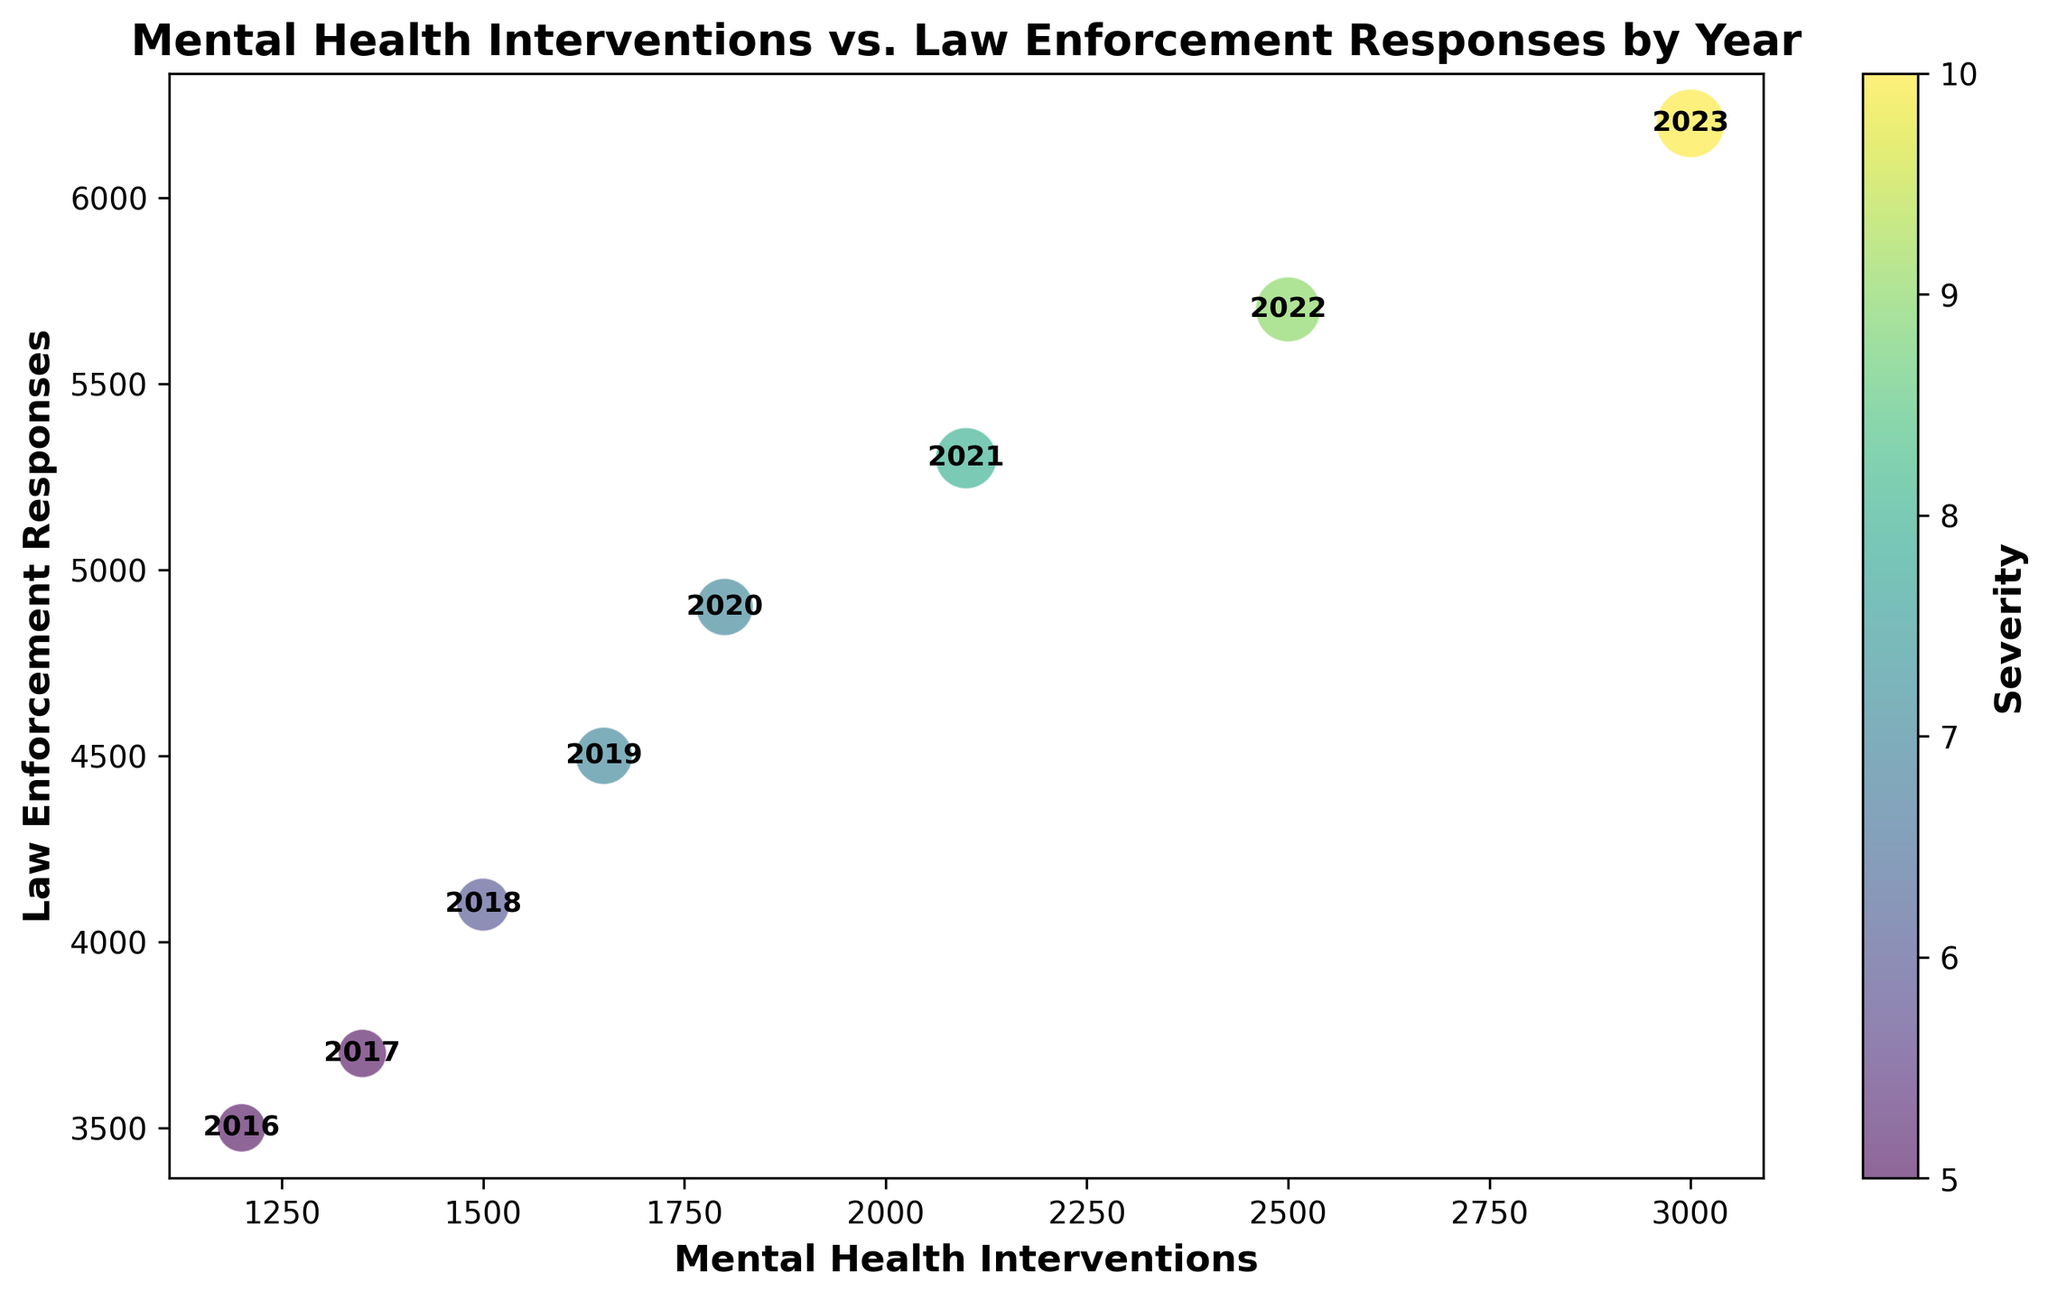What is the general trend of Mental Health Interventions from 2016 to 2023? By looking at the plot, you can see the bubbles representing Mental Health Interventions increase in value each year from left to right, indicating a consistent upward trend in the number of interventions from 2016 to 2023.
Answer: Increasing How does the number of Law Enforcement Responses in 2016 compare to 2023? By comparing the y-axis positions of the bubbles for 2016 and 2023, it is evident that the bubble for 2023 is higher than the one for 2016, indicating that Law Enforcement Responses have increased from 3500 in 2016 to 6200 in 2023.
Answer: Increased Which year had the highest severity level? By observing the size and color of the bubbles, the 2023 bubble is the largest and has the highest severity, represented by the deepest color, indicating the highest severity level of 10.
Answer: 2023 What is the difference in Mental Health Interventions between 2016 and 2023? The number of Mental Health Interventions for 2016 is 1200 and for 2023 is 3000. Subtracting the 2016 value from 2023 gives us 3000 - 1200 = 1800.
Answer: 1800 What is the ratio of Law Enforcement Responses to Mental Health Interventions in 2020? In 2020, there were 4900 Law Enforcement Responses and 1800 Mental Health Interventions. The ratio is 4900 / 1800 = 2.72.
Answer: 2.72 Which year saw the largest increase in Law Enforcement Responses compared to the previous year? By comparing the y-axis values year by year, the largest increase is between 2020 (4900) and 2021 (5300). The increase is 5300 - 4900 = 400.
Answer: 2021 Is the rate of increase in Mental Health Interventions consistent with the rate of increase in Law Enforcement Responses? Observing the bubble locations and sizes over the years, both metrics show an upward trend, but the rate of increase for Law Enforcement Responses is slightly greater compared to Mental Health Interventions.
Answer: No What is the average severity level from 2016 to 2023? The severity levels are 5, 5, 6, 7, 7, 8, 9, 10 for the years 2016 to 2023. Adding them up gives 5+5+6+7+7+8+9+10 = 57. Dividing by the number of years (8), the average is 57 / 8 = 7.13.
Answer: 7.13 Did any year experience a decline in Mental Health Interventions or Law Enforcement Responses? By observing the plot, all the bubbles show an upward trend year by year, indicating that neither Mental Health Interventions nor Law Enforcement Responses experienced a decline in any year.
Answer: No 